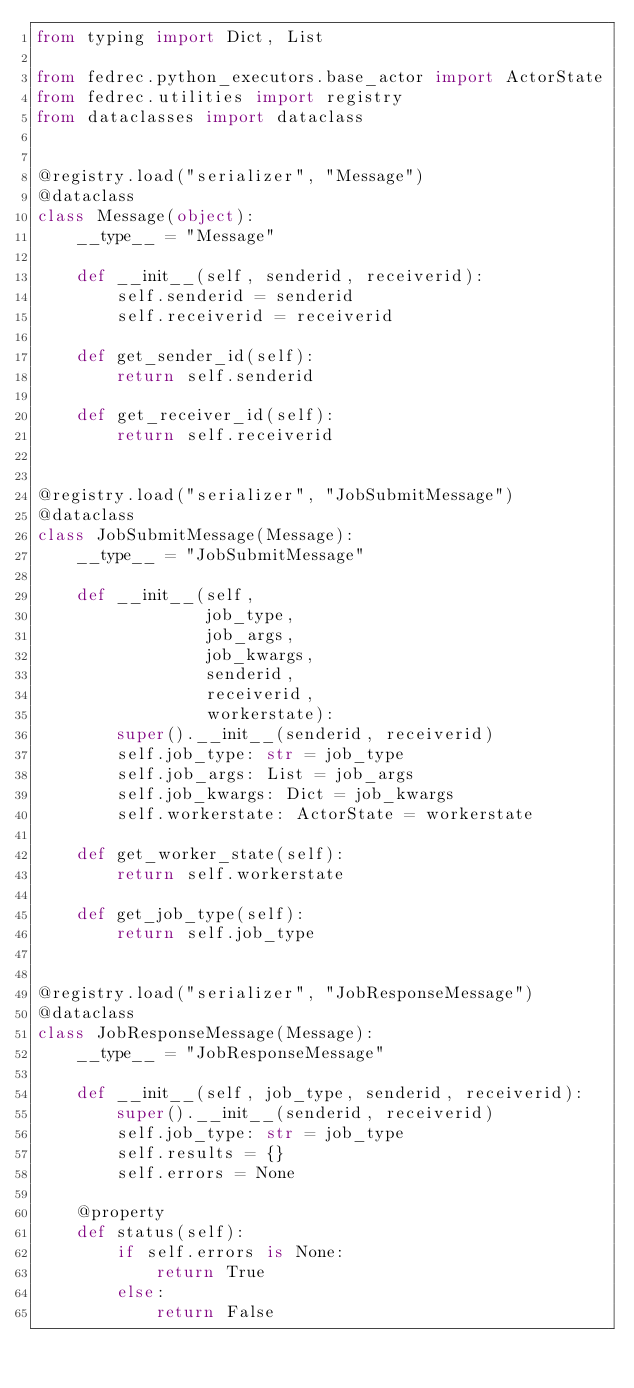Convert code to text. <code><loc_0><loc_0><loc_500><loc_500><_Python_>from typing import Dict, List

from fedrec.python_executors.base_actor import ActorState
from fedrec.utilities import registry
from dataclasses import dataclass


@registry.load("serializer", "Message")
@dataclass
class Message(object):
    __type__ = "Message"

    def __init__(self, senderid, receiverid):
        self.senderid = senderid
        self.receiverid = receiverid

    def get_sender_id(self):
        return self.senderid

    def get_receiver_id(self):
        return self.receiverid


@registry.load("serializer", "JobSubmitMessage")
@dataclass
class JobSubmitMessage(Message):
    __type__ = "JobSubmitMessage"

    def __init__(self,
                 job_type,
                 job_args,
                 job_kwargs,
                 senderid,
                 receiverid,
                 workerstate):
        super().__init__(senderid, receiverid)
        self.job_type: str = job_type
        self.job_args: List = job_args
        self.job_kwargs: Dict = job_kwargs
        self.workerstate: ActorState = workerstate

    def get_worker_state(self):
        return self.workerstate

    def get_job_type(self):
        return self.job_type


@registry.load("serializer", "JobResponseMessage")
@dataclass
class JobResponseMessage(Message):
    __type__ = "JobResponseMessage"

    def __init__(self, job_type, senderid, receiverid):
        super().__init__(senderid, receiverid)
        self.job_type: str = job_type
        self.results = {}
        self.errors = None

    @property
    def status(self):
        if self.errors is None:
            return True
        else:
            return False
</code> 